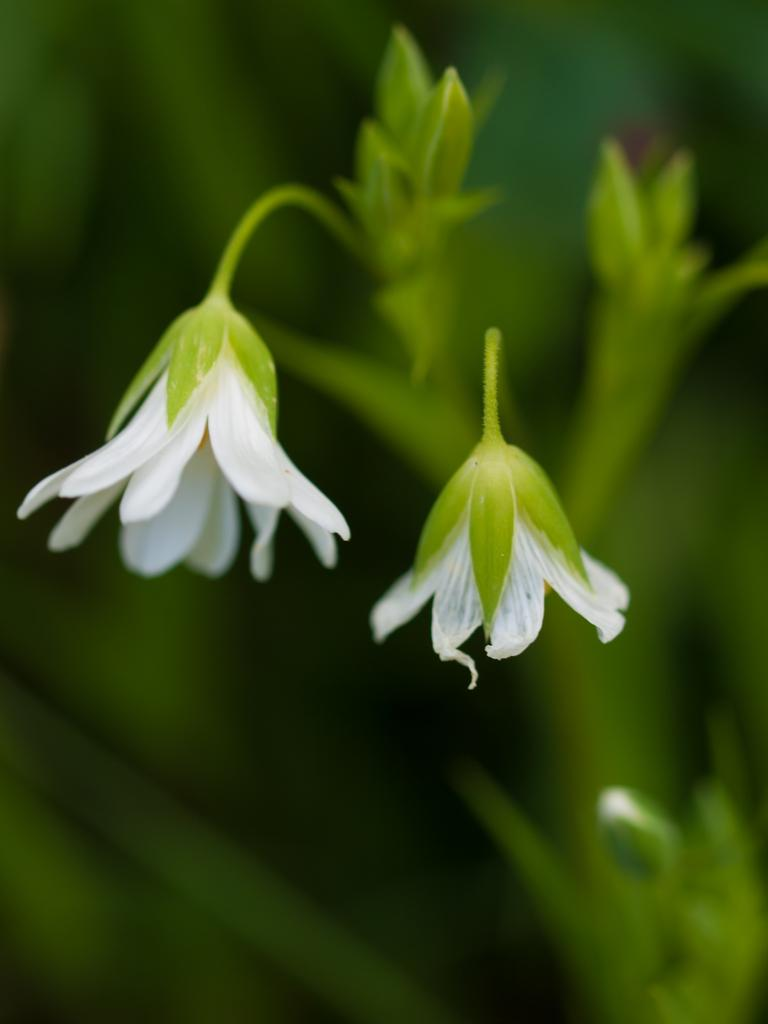How many flowers are visible in the image? There are two white flowers in the image. What color are the flowers? The flowers are white. What is the flowers attached to? The flowers are attached to a green plant. What can be seen in the background of the image? The background of the image is green and blurry. What does your aunt say when she sees the flowers in the image? There is no mention of an aunt in the image, so it is not possible to answer that question. 